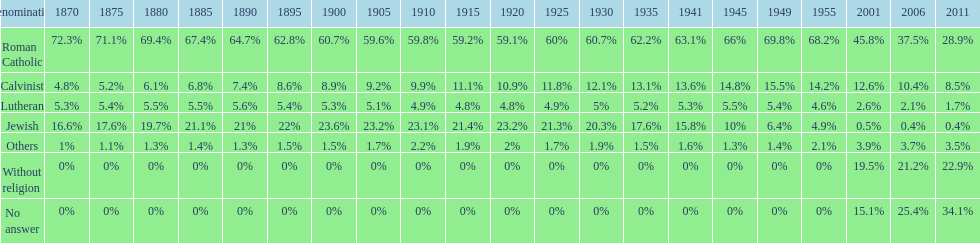How many religious groups never decreased under 20%? 1. 